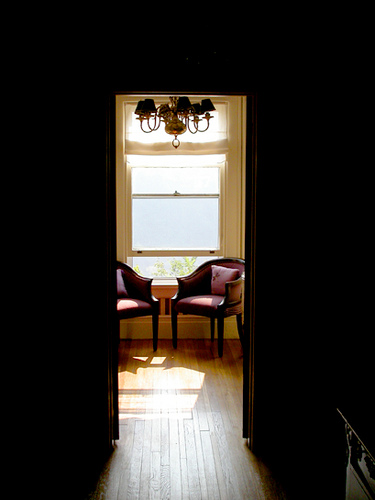<image>
Is the chair above the floor? No. The chair is not positioned above the floor. The vertical arrangement shows a different relationship. Is the chair behind the window? No. The chair is not behind the window. From this viewpoint, the chair appears to be positioned elsewhere in the scene. 